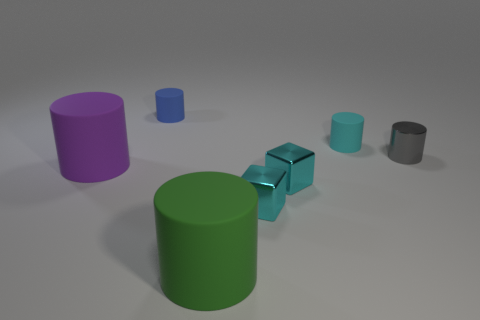Subtract all cyan rubber cylinders. How many cylinders are left? 4 Add 2 tiny blue matte objects. How many objects exist? 9 Subtract all cylinders. How many objects are left? 2 Subtract all purple cylinders. How many cylinders are left? 4 Subtract 3 cylinders. How many cylinders are left? 2 Subtract all red cylinders. Subtract all yellow cubes. How many cylinders are left? 5 Subtract all small brown balls. Subtract all big purple matte cylinders. How many objects are left? 6 Add 4 cyan matte things. How many cyan matte things are left? 5 Add 6 blue cubes. How many blue cubes exist? 6 Subtract 0 green spheres. How many objects are left? 7 